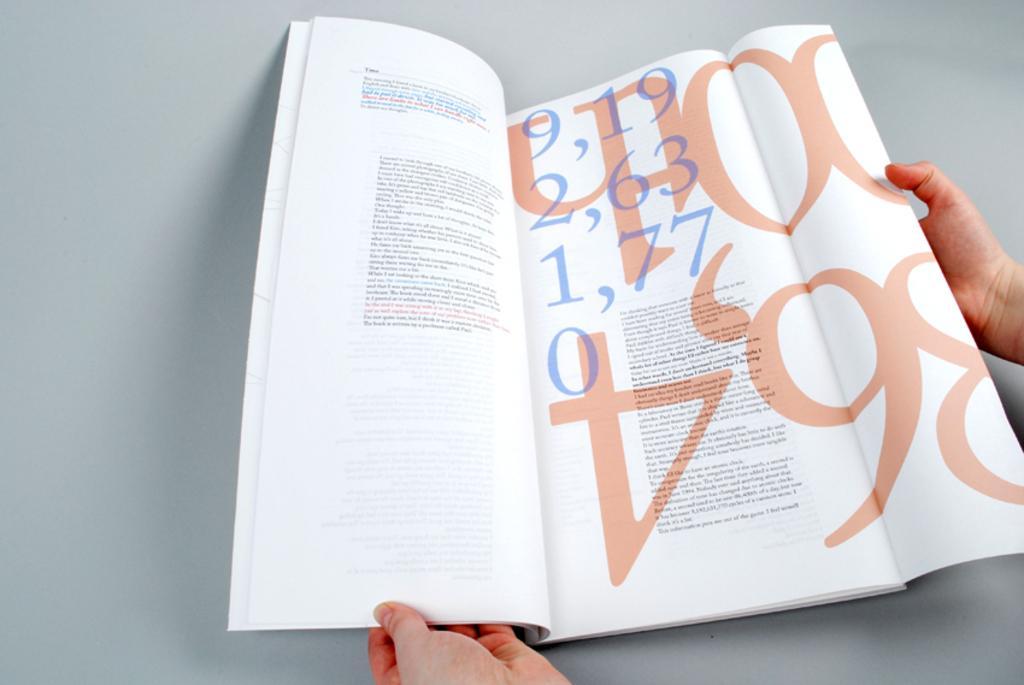Describe this image in one or two sentences. In this image we can see the hands of a person holding a book containing some text in it which is placed on the surface. 